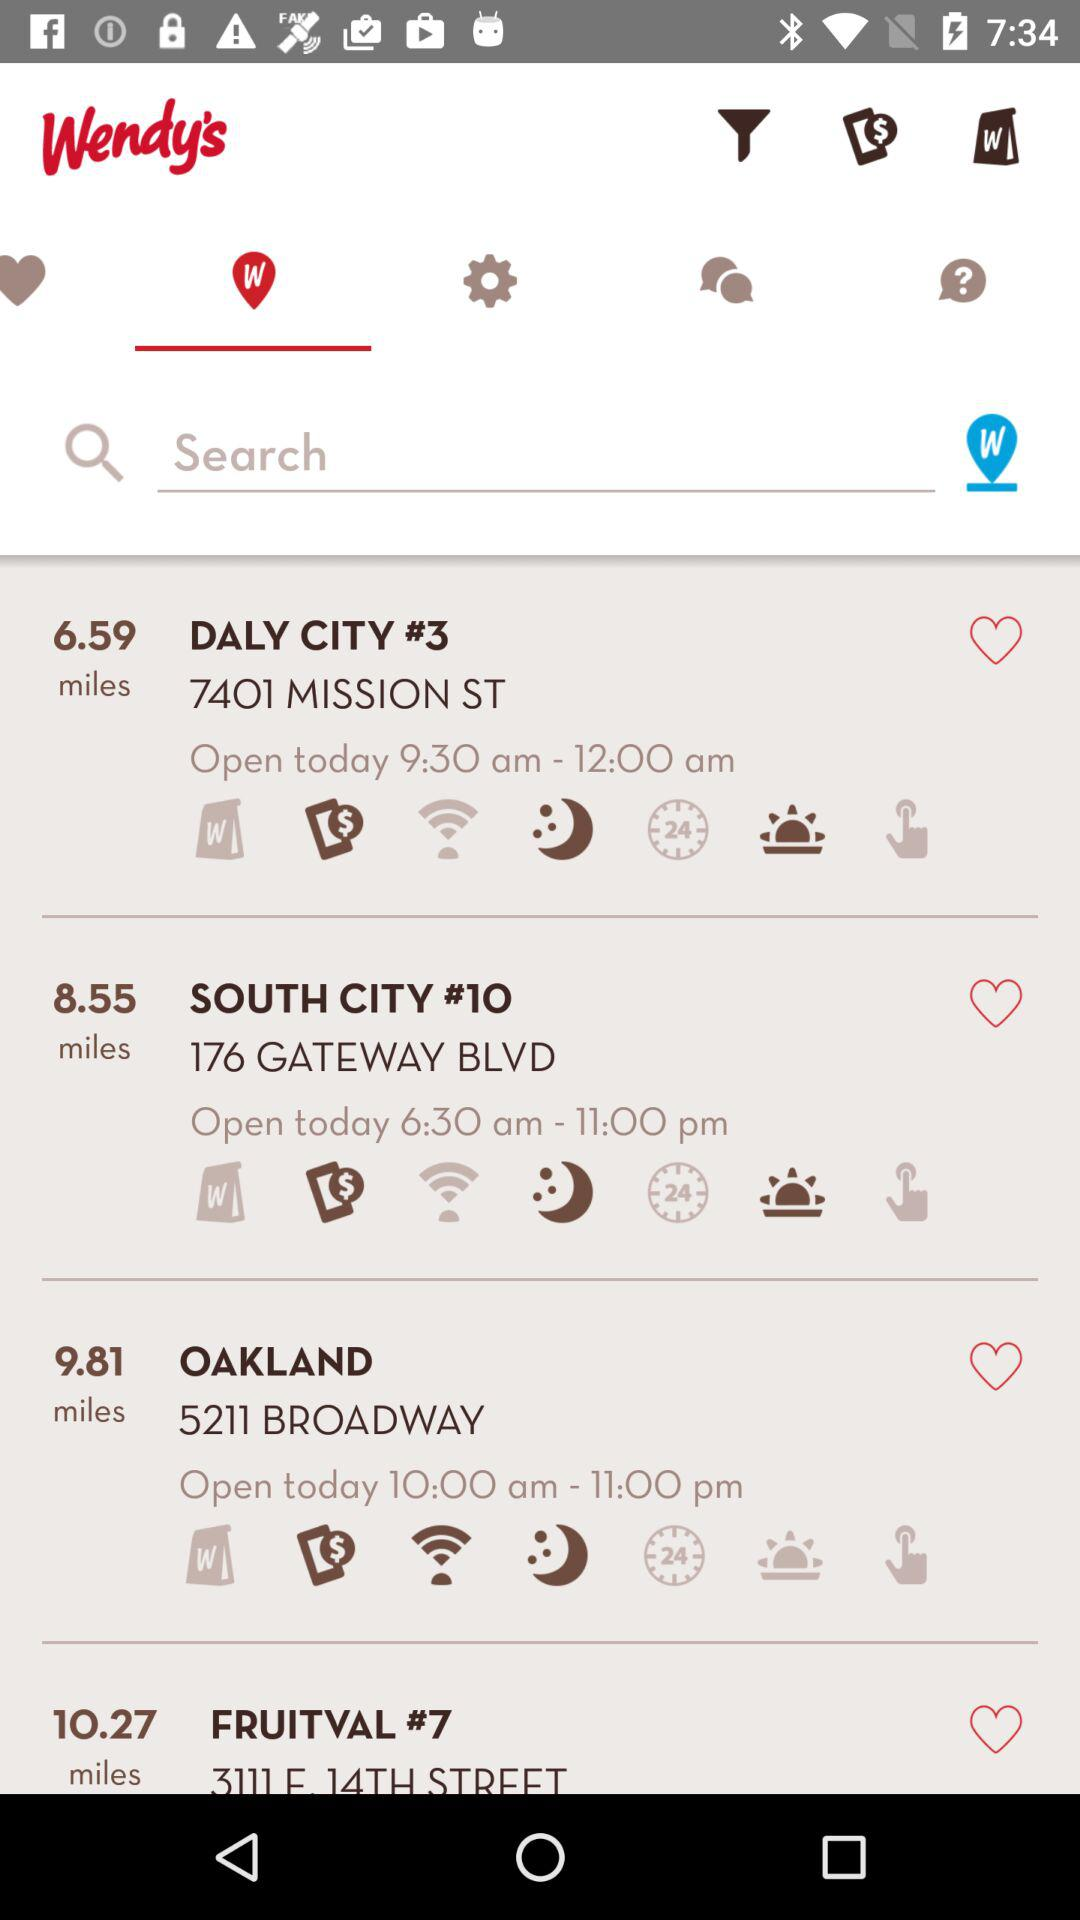What's the time to open today for Daly City #3? The time is 9:30 AM. 